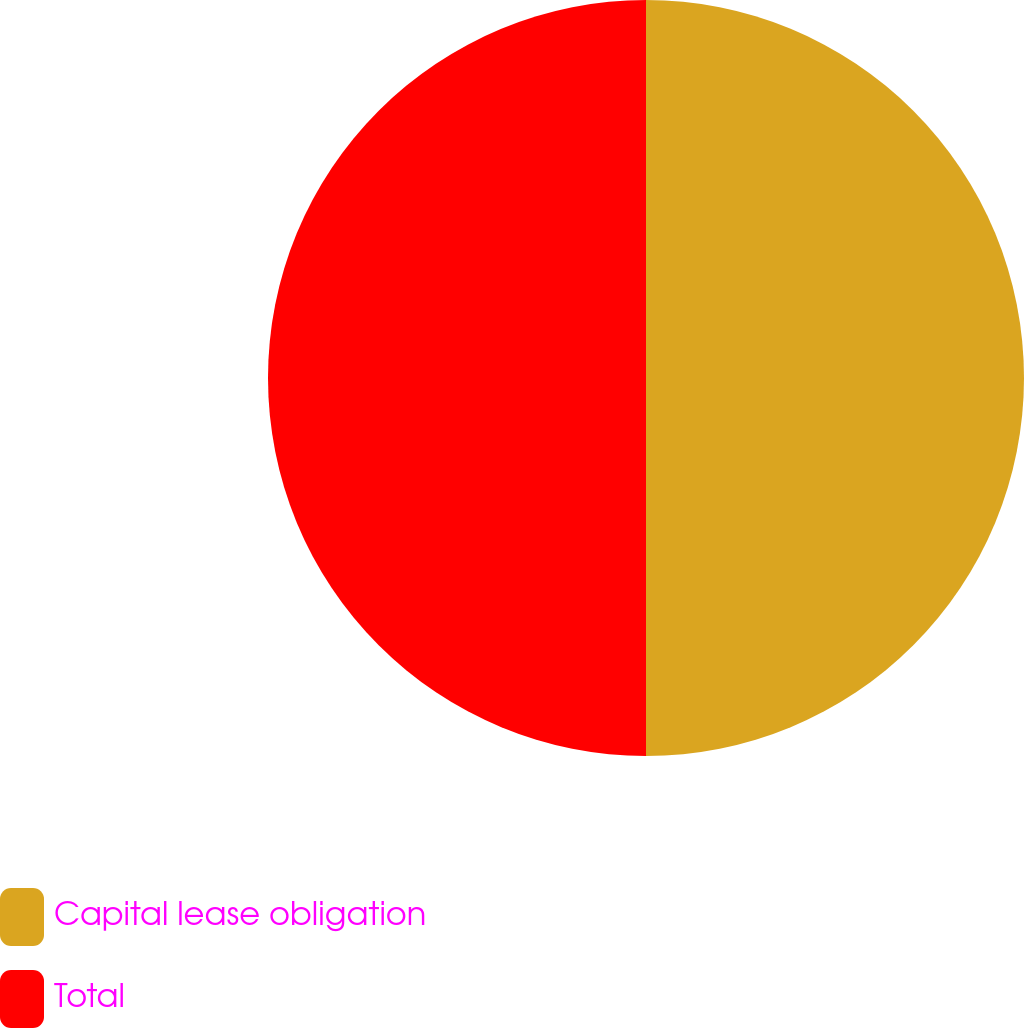<chart> <loc_0><loc_0><loc_500><loc_500><pie_chart><fcel>Capital lease obligation<fcel>Total<nl><fcel>50.0%<fcel>50.0%<nl></chart> 